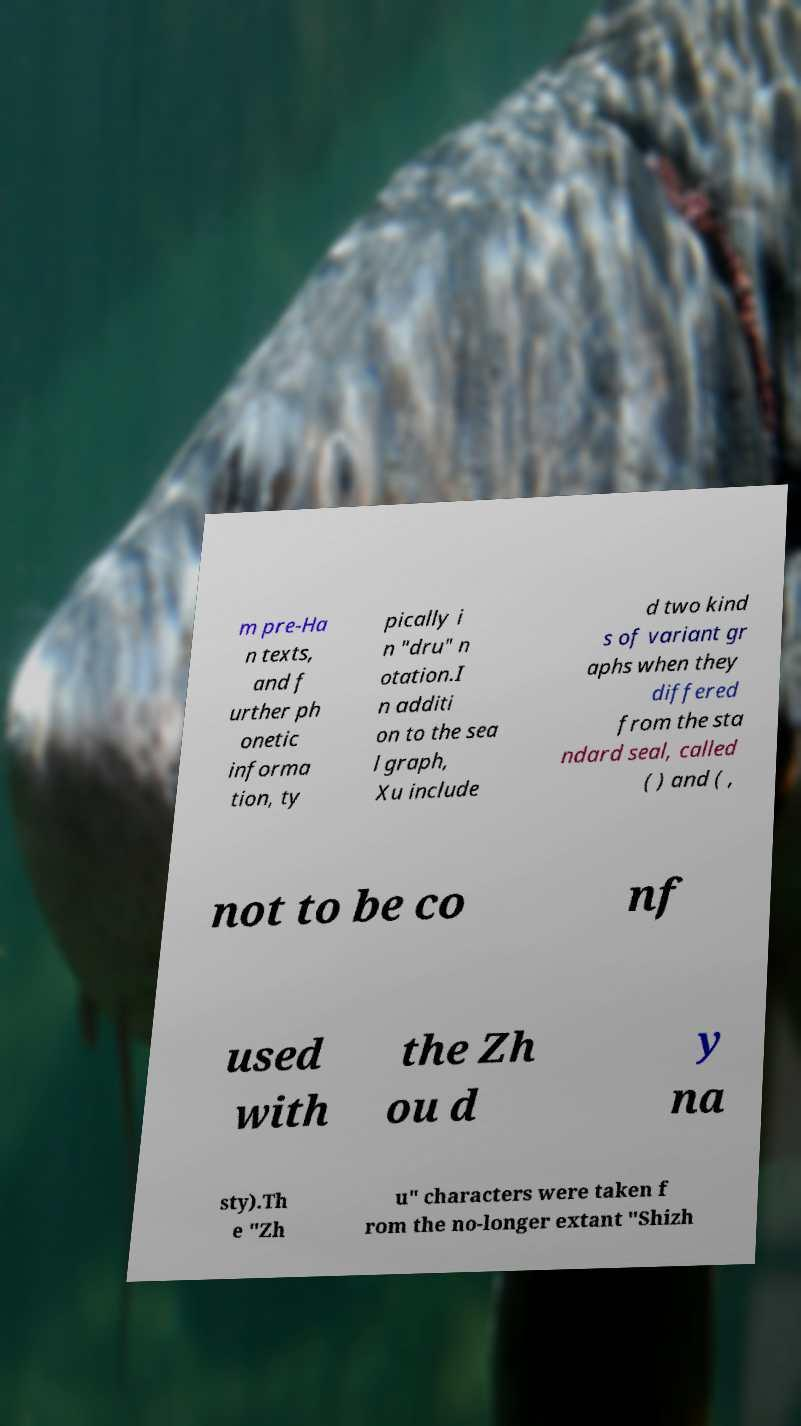Can you read and provide the text displayed in the image?This photo seems to have some interesting text. Can you extract and type it out for me? m pre-Ha n texts, and f urther ph onetic informa tion, ty pically i n "dru" n otation.I n additi on to the sea l graph, Xu include d two kind s of variant gr aphs when they differed from the sta ndard seal, called ( ) and ( , not to be co nf used with the Zh ou d y na sty).Th e "Zh u" characters were taken f rom the no-longer extant "Shizh 